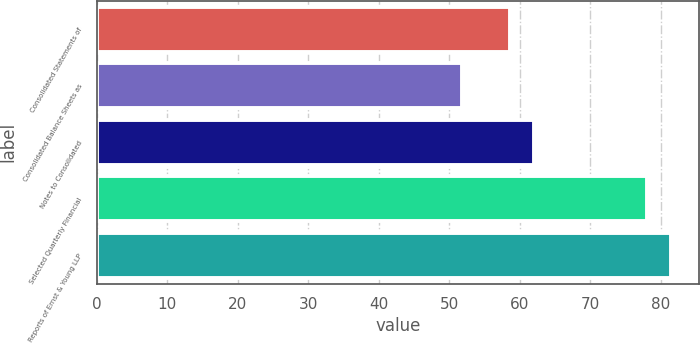<chart> <loc_0><loc_0><loc_500><loc_500><bar_chart><fcel>Consolidated Statements of<fcel>Consolidated Balance Sheets as<fcel>Notes to Consolidated<fcel>Selected Quarterly Financial<fcel>Reports of Ernst & Young LLP<nl><fcel>58.6<fcel>51.8<fcel>62<fcel>78<fcel>81.4<nl></chart> 